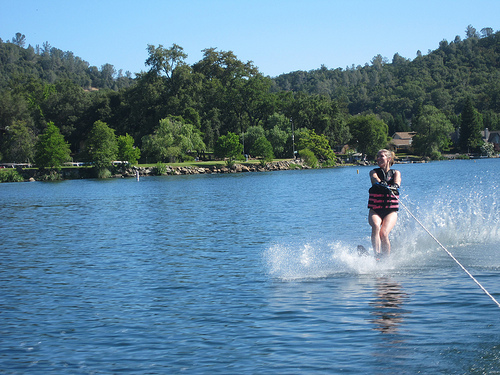What activity is the person in the image doing? The person is water skiing, a sport where an individual is pulled behind a boat or a cable ski installation over the water's surface. 